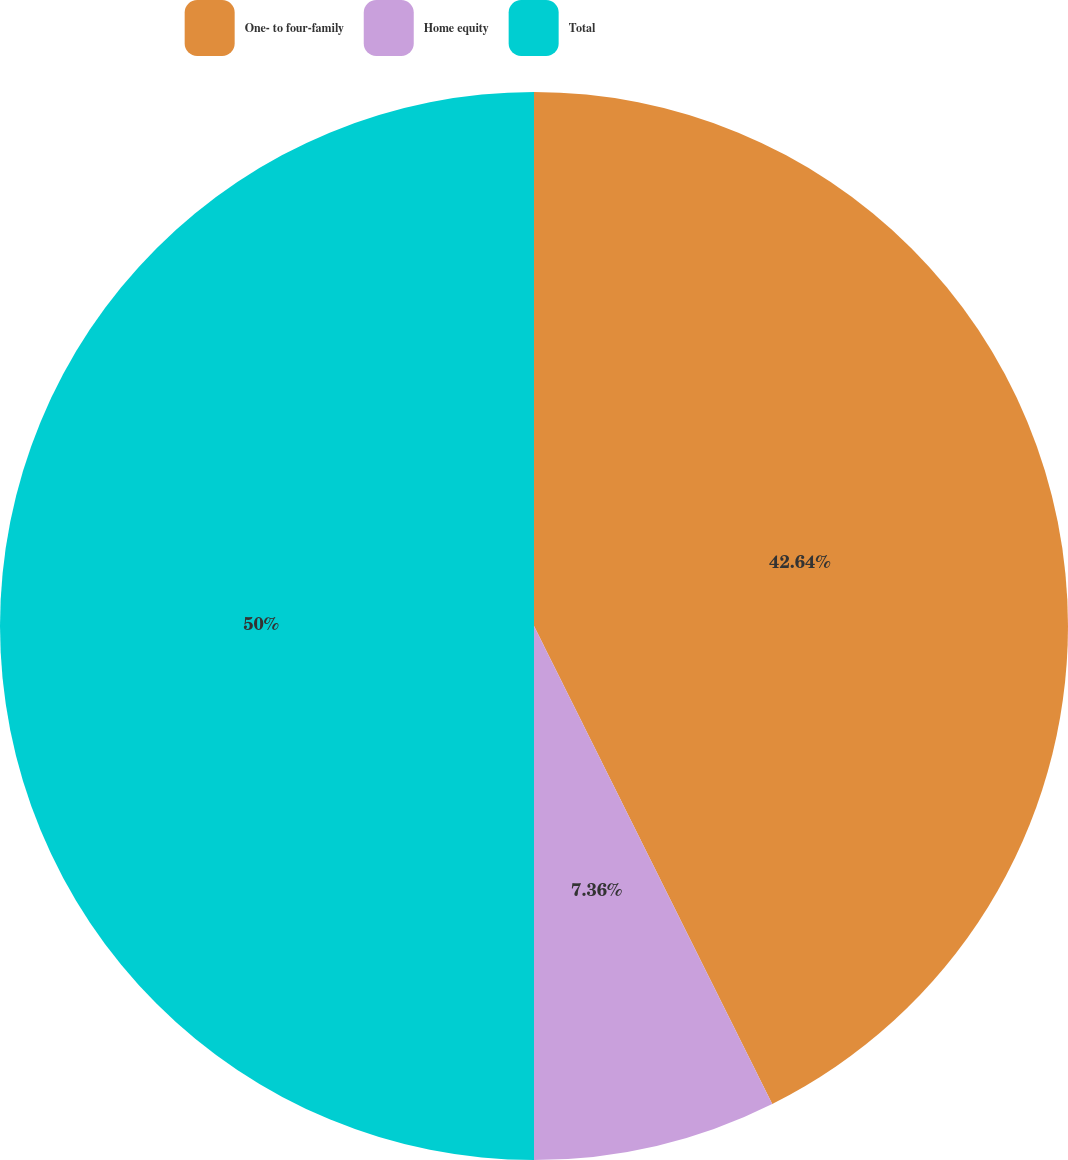Convert chart. <chart><loc_0><loc_0><loc_500><loc_500><pie_chart><fcel>One- to four-family<fcel>Home equity<fcel>Total<nl><fcel>42.64%<fcel>7.36%<fcel>50.0%<nl></chart> 